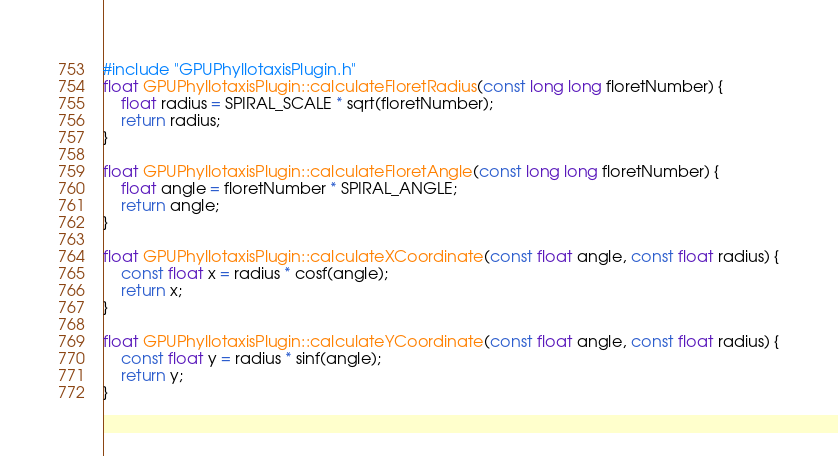<code> <loc_0><loc_0><loc_500><loc_500><_Cuda_>#include "GPUPhyllotaxisPlugin.h"
float GPUPhyllotaxisPlugin::calculateFloretRadius(const long long floretNumber) {
	float radius = SPIRAL_SCALE * sqrt(floretNumber);
	return radius;
}

float GPUPhyllotaxisPlugin::calculateFloretAngle(const long long floretNumber) {
	float angle = floretNumber * SPIRAL_ANGLE;
	return angle;
}

float GPUPhyllotaxisPlugin::calculateXCoordinate(const float angle, const float radius) {
	const float x = radius * cosf(angle);
	return x;
}

float GPUPhyllotaxisPlugin::calculateYCoordinate(const float angle, const float radius) {
	const float y = radius * sinf(angle);
	return y;
}
</code> 